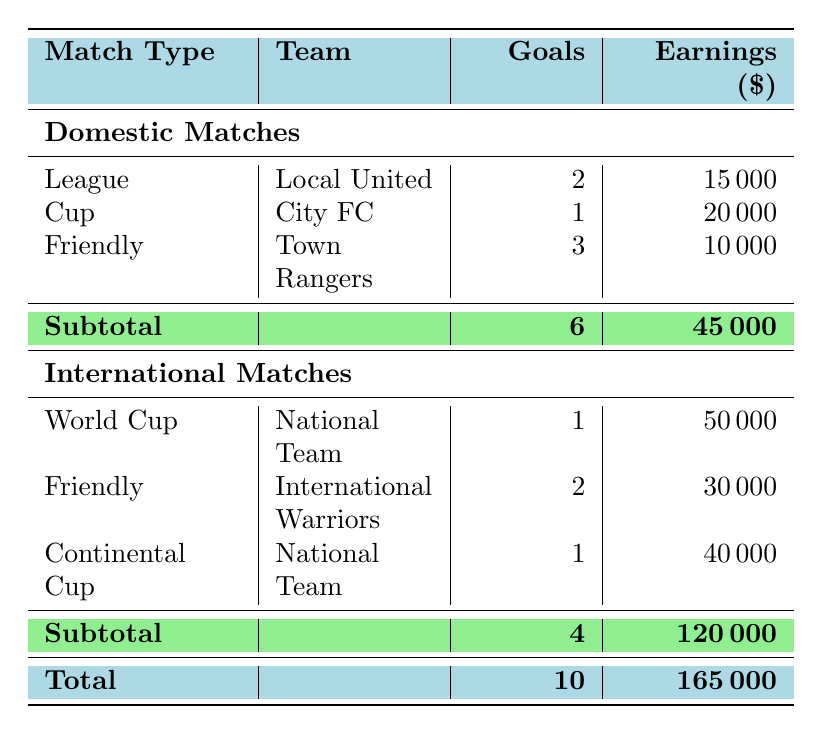What is the total earnings from Domestic Matches? To find the total earnings from Domestic Matches, we need to add the earnings from each match: 15000 (League) + 20000 (Cup) + 10000 (Friendly) = 45000.
Answer: 45000 How many goals did John Smith score in International Matches? To get the total number of goals scored in International Matches, we add the goals scored in each match: 1 (World Cup) + 2 (Friendly) + 1 (Continental Cup) = 4.
Answer: 4 What match type generated the highest earnings in Domestic Matches? In Domestic Matches, the earnings are: League - 15000, Cup - 20000, Friendly - 10000. The highest earnings come from the Cup match against City FC, which earned 20000.
Answer: Cup Did John Smith earn more from Domestic Matches than International Matches? The earnings from Domestic Matches are 45000, while the earnings from International Matches are 120000. Since 45000 is less than 120000, the statement is false.
Answer: No What is the average earnings per goal in International Matches? To find the average earnings per goal in International Matches, we first calculate total earnings (120000) and total goals (4). Then, we divide total earnings by total goals: 120000 / 4 = 30000.
Answer: 30000 What was John Smith's highest individual match earnings, and in what match? Among the individual earnings, we see earnings of 15000 (League), 20000 (Cup), 10000 (Friendly) in Domestic Matches and 50000 (World Cup), 30000 (Friendly), 40000 (Continental Cup) in International Matches. The highest individual earning was 50000 from the World Cup match.
Answer: 50000 (World Cup) What was the total number of goals scored across all matches? To find the total goals scored, we need to combine goals from both Domestic Matches (6) and International Matches (4). Therefore, 6 + 4 = 10 goals scored in total across all matches.
Answer: 10 Which type of match contributed more to John Smith's overall earnings, domestic or international? Domestic Matches contributed earnings of 45000, while International Matches contributed earnings of 120000. Since 120000 is greater than 45000, International Matches contributed more to his overall earnings.
Answer: International Matches How much more did John Smith earn from International Matches than from Domestic Matches? To determine the difference in earnings: 120000 (International) - 45000 (Domestic) = 75000. John Smith earned 75000 more from International Matches.
Answer: 75000 